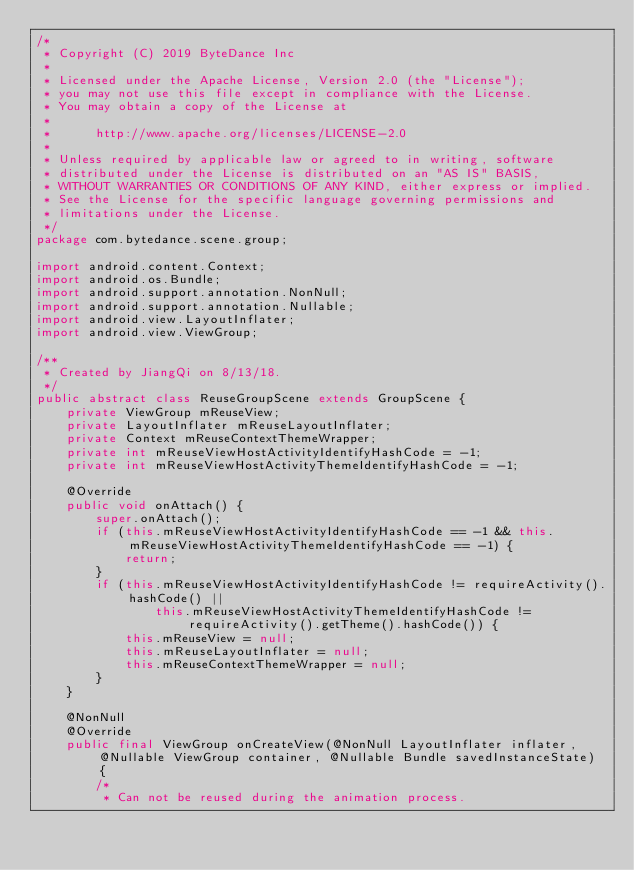<code> <loc_0><loc_0><loc_500><loc_500><_Java_>/*
 * Copyright (C) 2019 ByteDance Inc
 *
 * Licensed under the Apache License, Version 2.0 (the "License");
 * you may not use this file except in compliance with the License.
 * You may obtain a copy of the License at
 *
 *      http://www.apache.org/licenses/LICENSE-2.0
 *
 * Unless required by applicable law or agreed to in writing, software
 * distributed under the License is distributed on an "AS IS" BASIS,
 * WITHOUT WARRANTIES OR CONDITIONS OF ANY KIND, either express or implied.
 * See the License for the specific language governing permissions and
 * limitations under the License.
 */
package com.bytedance.scene.group;

import android.content.Context;
import android.os.Bundle;
import android.support.annotation.NonNull;
import android.support.annotation.Nullable;
import android.view.LayoutInflater;
import android.view.ViewGroup;

/**
 * Created by JiangQi on 8/13/18.
 */
public abstract class ReuseGroupScene extends GroupScene {
    private ViewGroup mReuseView;
    private LayoutInflater mReuseLayoutInflater;
    private Context mReuseContextThemeWrapper;
    private int mReuseViewHostActivityIdentifyHashCode = -1;
    private int mReuseViewHostActivityThemeIdentifyHashCode = -1;

    @Override
    public void onAttach() {
        super.onAttach();
        if (this.mReuseViewHostActivityIdentifyHashCode == -1 && this.mReuseViewHostActivityThemeIdentifyHashCode == -1) {
            return;
        }
        if (this.mReuseViewHostActivityIdentifyHashCode != requireActivity().hashCode() ||
                this.mReuseViewHostActivityThemeIdentifyHashCode != requireActivity().getTheme().hashCode()) {
            this.mReuseView = null;
            this.mReuseLayoutInflater = null;
            this.mReuseContextThemeWrapper = null;
        }
    }

    @NonNull
    @Override
    public final ViewGroup onCreateView(@NonNull LayoutInflater inflater, @Nullable ViewGroup container, @Nullable Bundle savedInstanceState) {
        /*
         * Can not be reused during the animation process.</code> 